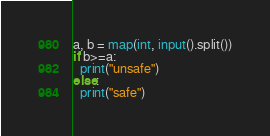<code> <loc_0><loc_0><loc_500><loc_500><_Python_>a, b = map(int, input().split())
if b>=a:
  print("unsafe")
else:
  print("safe")</code> 